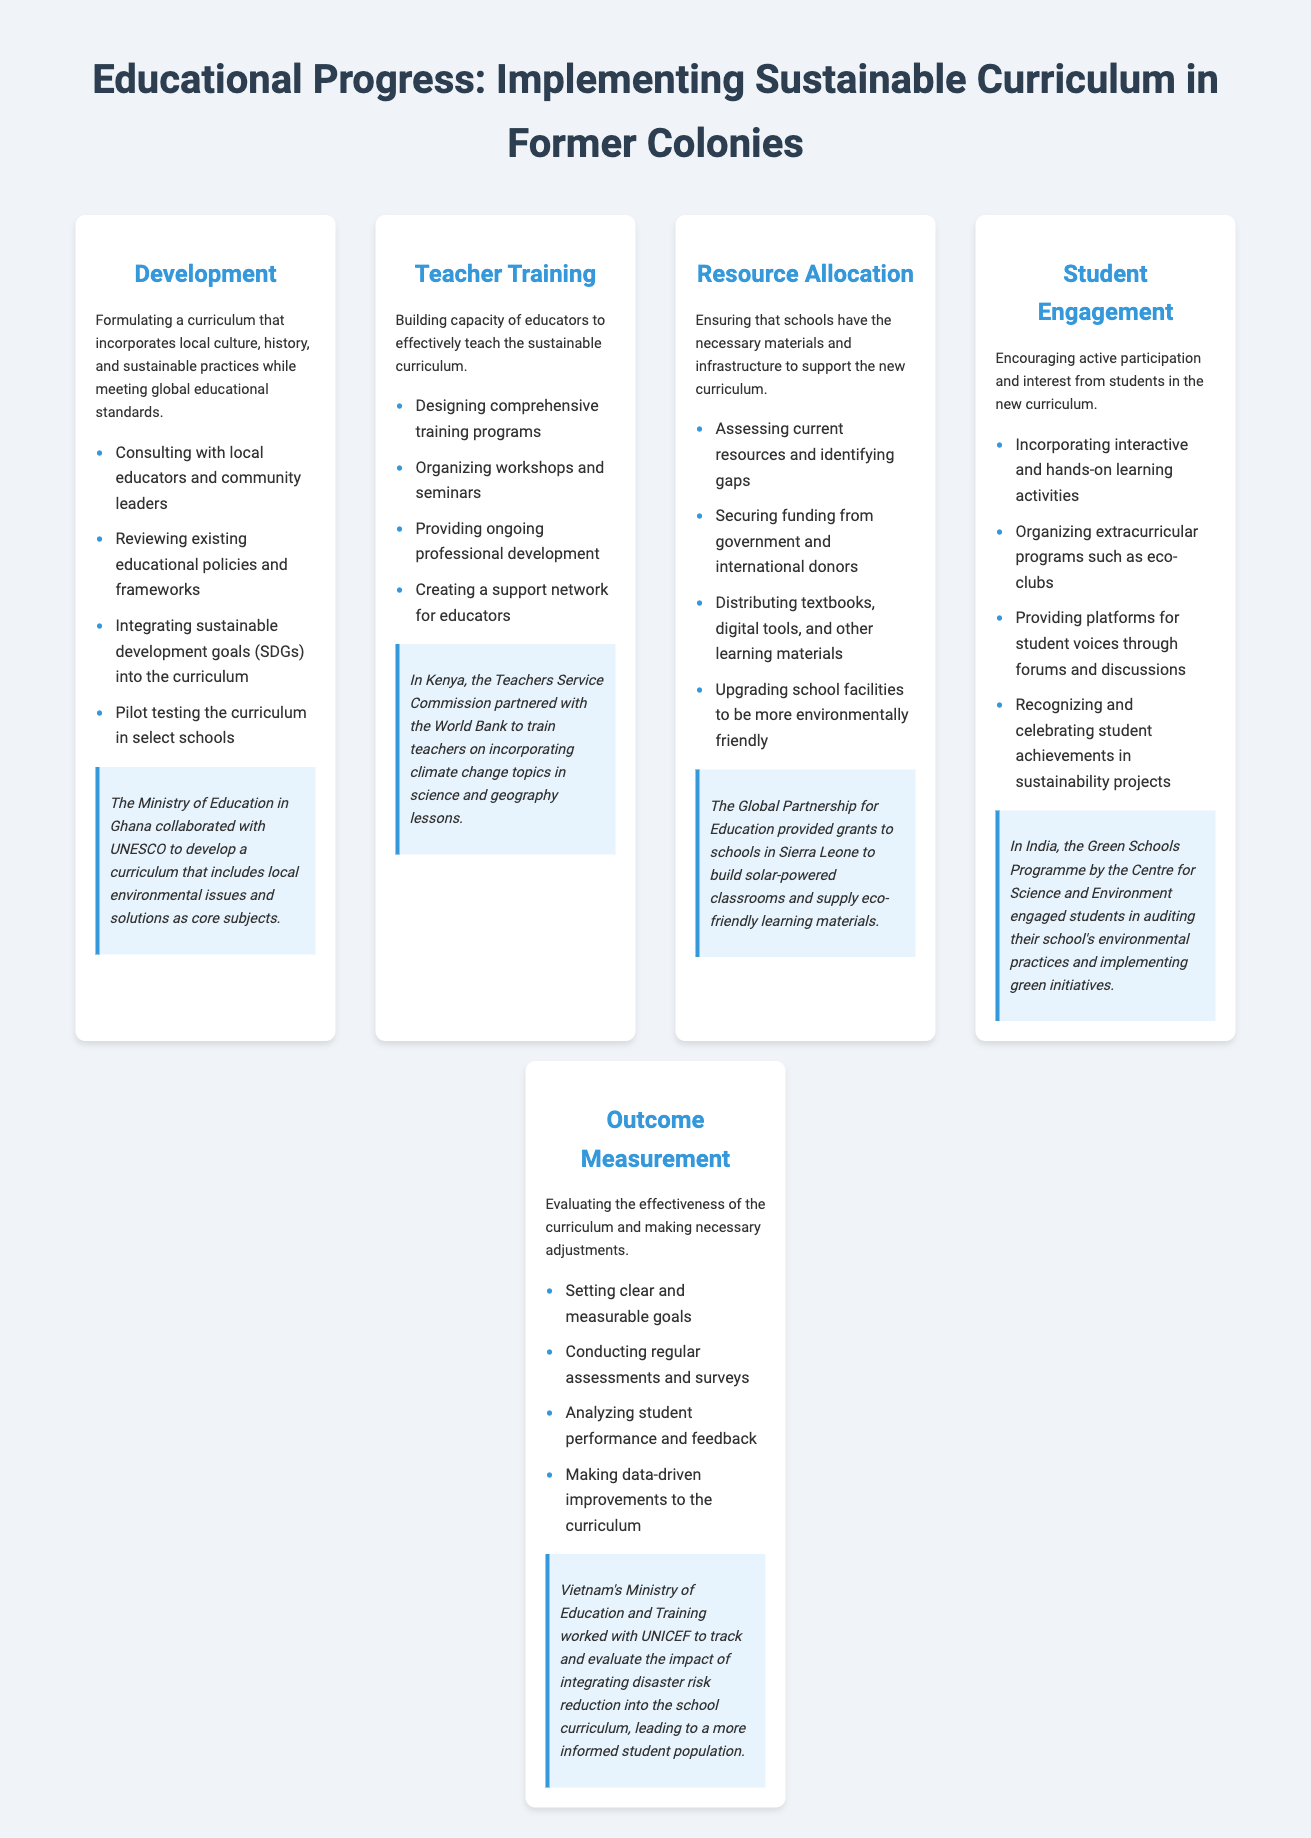What is the first step in the process? The first step in the process is "Development," which involves formulating a sustainable curriculum.
Answer: Development What group collaborated with Ghana's Ministry of Education? The Ministry of Education in Ghana collaborated with UNESCO to develop the curriculum.
Answer: UNESCO What type of programs were organized in the teacher training step? The training step involved organizing workshops and seminars to build educators' capacity.
Answer: Workshops and seminars What is one example of student engagement activities? One student engagement activity mentioned is organizing extracurricular programs such as eco-clubs.
Answer: Eco-clubs Which organization provided grants for solar-powered classrooms in Sierra Leone? The Global Partnership for Education provided grants to schools in Sierra Leone.
Answer: Global Partnership for Education How does the outcome measurement process analyze effectiveness? The outcome measurement process analyzes effectiveness by conducting regular assessments and surveys.
Answer: Assessments and surveys What is one focus of the development step? One focus of the development step is integrating sustainable development goals into the curriculum.
Answer: Sustainable development goals Which country’s education ministry worked with UNICEF on disaster risk reduction? Vietnam's Ministry of Education and Training worked with UNICEF on disaster risk reduction.
Answer: Vietnam What is a key goal for teachers during the teacher training phase? A key goal for teachers is to effectively teach the sustainable curriculum.
Answer: Effectively teach the sustainable curriculum 